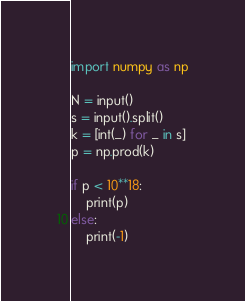<code> <loc_0><loc_0><loc_500><loc_500><_Python_>import numpy as np

N = input()
s = input().split()
k = [int(_) for _ in s]
p = np.prod(k)

if p < 10**18:
    print(p)
else:
    print(-1)</code> 